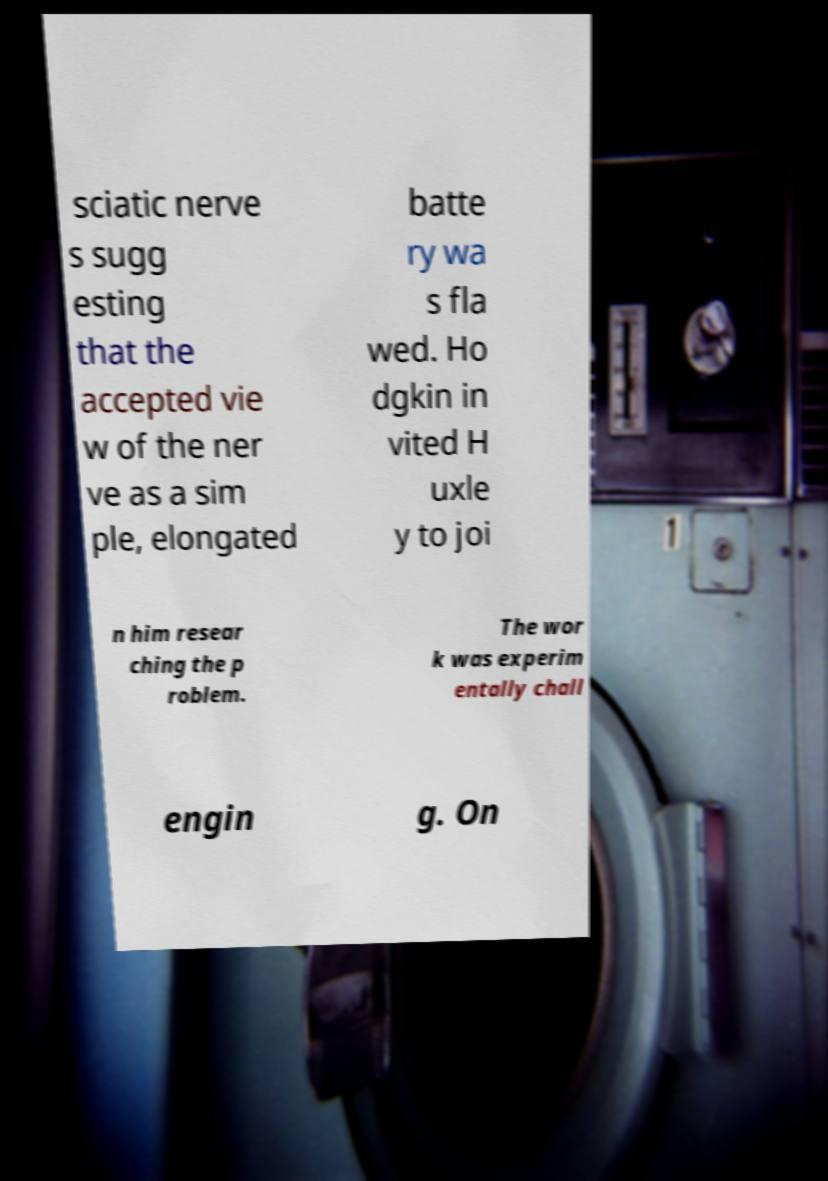Can you read and provide the text displayed in the image?This photo seems to have some interesting text. Can you extract and type it out for me? sciatic nerve s sugg esting that the accepted vie w of the ner ve as a sim ple, elongated batte ry wa s fla wed. Ho dgkin in vited H uxle y to joi n him resear ching the p roblem. The wor k was experim entally chall engin g. On 